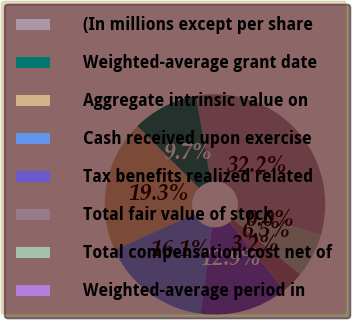<chart> <loc_0><loc_0><loc_500><loc_500><pie_chart><fcel>(In millions except per share<fcel>Weighted-average grant date<fcel>Aggregate intrinsic value on<fcel>Cash received upon exercise<fcel>Tax benefits realized related<fcel>Total fair value of stock<fcel>Total compensation cost net of<fcel>Weighted-average period in<nl><fcel>32.21%<fcel>9.68%<fcel>19.34%<fcel>16.12%<fcel>12.9%<fcel>3.25%<fcel>6.47%<fcel>0.03%<nl></chart> 